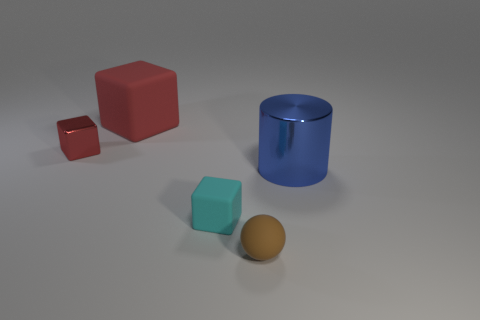Subtract all tiny blocks. How many blocks are left? 1 Add 2 large matte balls. How many objects exist? 7 Subtract all red blocks. How many blocks are left? 1 Subtract 2 blocks. How many blocks are left? 1 Subtract all spheres. How many objects are left? 4 Subtract all yellow cubes. Subtract all blue spheres. How many cubes are left? 3 Subtract all purple spheres. How many cyan cylinders are left? 0 Subtract all red metallic things. Subtract all big red objects. How many objects are left? 3 Add 4 brown objects. How many brown objects are left? 5 Add 1 brown matte things. How many brown matte things exist? 2 